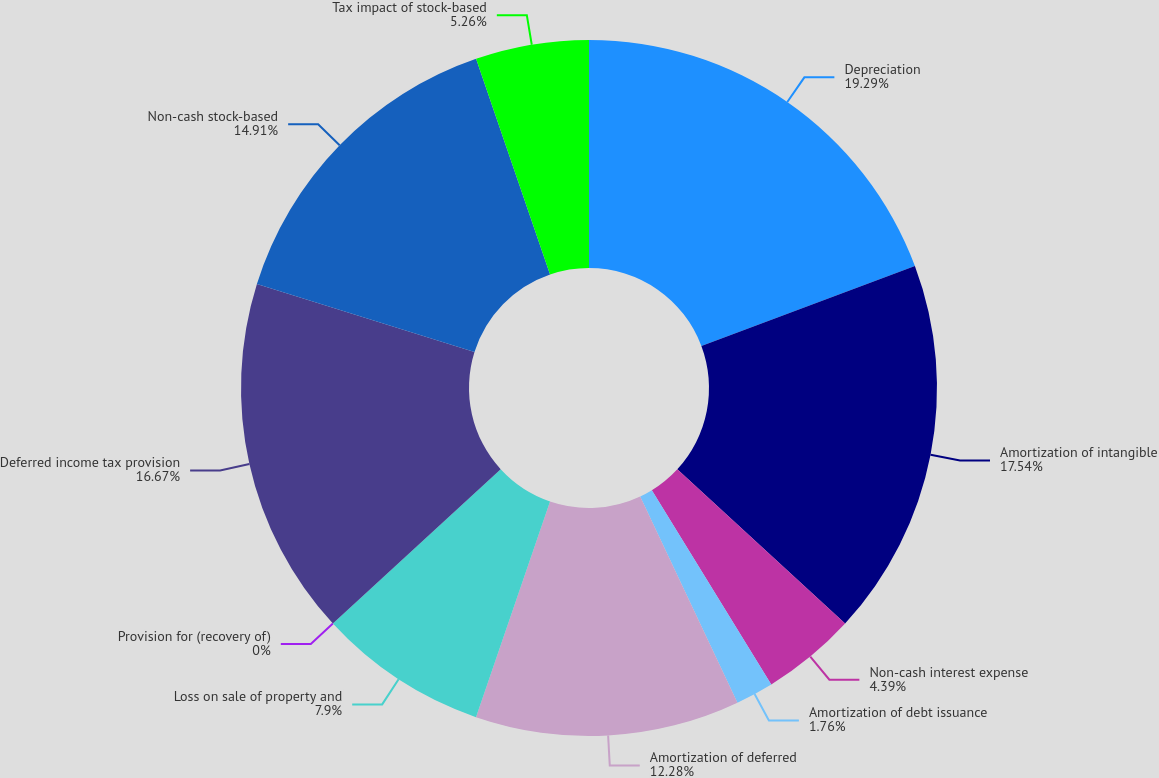Convert chart to OTSL. <chart><loc_0><loc_0><loc_500><loc_500><pie_chart><fcel>Depreciation<fcel>Amortization of intangible<fcel>Non-cash interest expense<fcel>Amortization of debt issuance<fcel>Amortization of deferred<fcel>Loss on sale of property and<fcel>Provision for (recovery of)<fcel>Deferred income tax provision<fcel>Non-cash stock-based<fcel>Tax impact of stock-based<nl><fcel>19.3%<fcel>17.54%<fcel>4.39%<fcel>1.76%<fcel>12.28%<fcel>7.9%<fcel>0.0%<fcel>16.67%<fcel>14.91%<fcel>5.26%<nl></chart> 